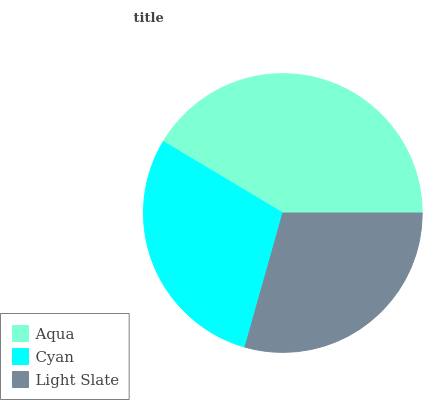Is Cyan the minimum?
Answer yes or no. Yes. Is Aqua the maximum?
Answer yes or no. Yes. Is Light Slate the minimum?
Answer yes or no. No. Is Light Slate the maximum?
Answer yes or no. No. Is Light Slate greater than Cyan?
Answer yes or no. Yes. Is Cyan less than Light Slate?
Answer yes or no. Yes. Is Cyan greater than Light Slate?
Answer yes or no. No. Is Light Slate less than Cyan?
Answer yes or no. No. Is Light Slate the high median?
Answer yes or no. Yes. Is Light Slate the low median?
Answer yes or no. Yes. Is Cyan the high median?
Answer yes or no. No. Is Aqua the low median?
Answer yes or no. No. 